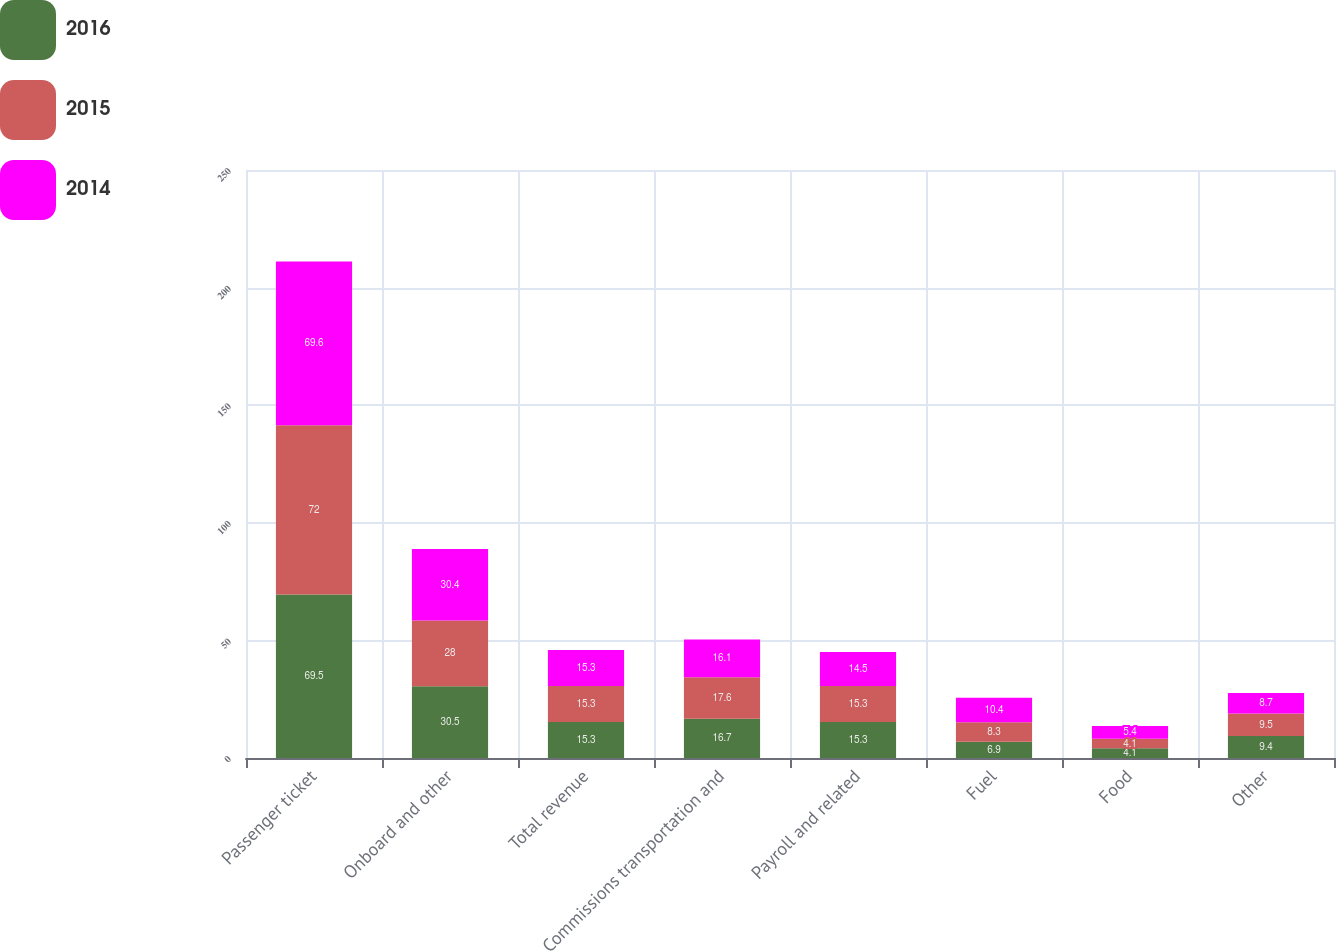<chart> <loc_0><loc_0><loc_500><loc_500><stacked_bar_chart><ecel><fcel>Passenger ticket<fcel>Onboard and other<fcel>Total revenue<fcel>Commissions transportation and<fcel>Payroll and related<fcel>Fuel<fcel>Food<fcel>Other<nl><fcel>2016<fcel>69.5<fcel>30.5<fcel>15.3<fcel>16.7<fcel>15.3<fcel>6.9<fcel>4.1<fcel>9.4<nl><fcel>2015<fcel>72<fcel>28<fcel>15.3<fcel>17.6<fcel>15.3<fcel>8.3<fcel>4.1<fcel>9.5<nl><fcel>2014<fcel>69.6<fcel>30.4<fcel>15.3<fcel>16.1<fcel>14.5<fcel>10.4<fcel>5.4<fcel>8.7<nl></chart> 